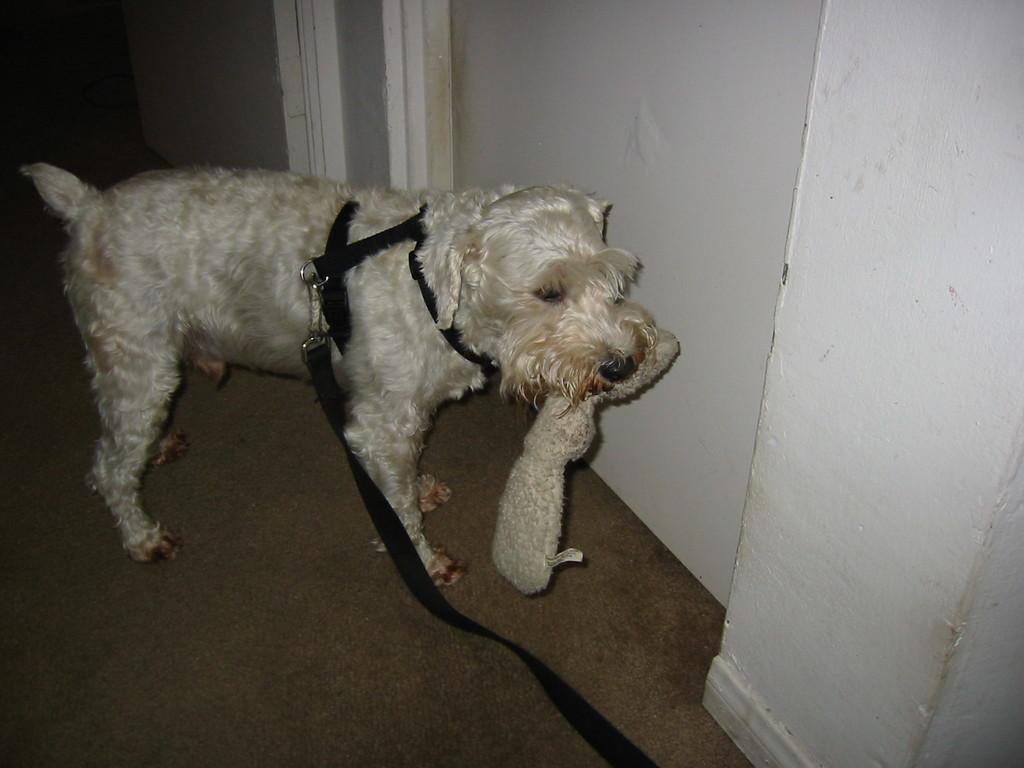Could you give a brief overview of what you see in this image? In this picture we can see a white dog with a black belt around his neck. The dog is holding something in his mouth and standing on the floor in front of a white wall. 